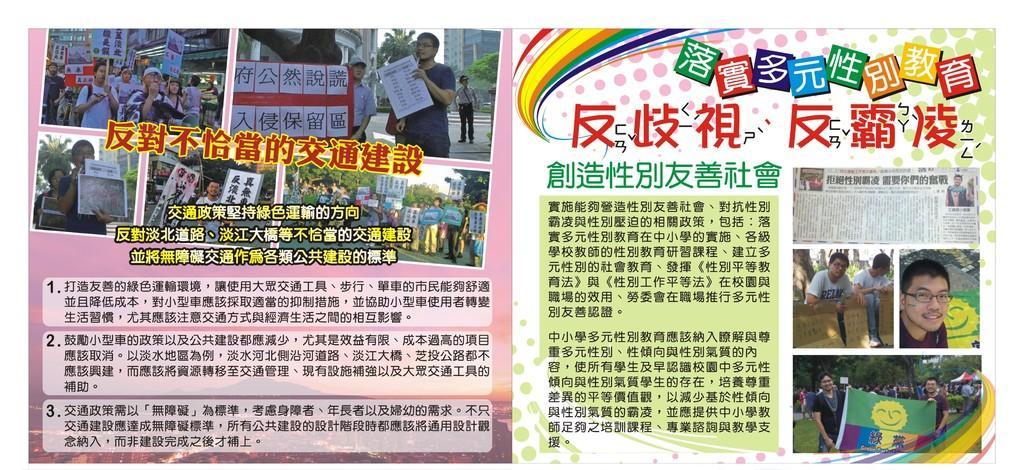Describe this image in one or two sentences. In the picture we can see some people are holding a board with some information on it and behind them, we can see some trees and building and we can also see an article. 